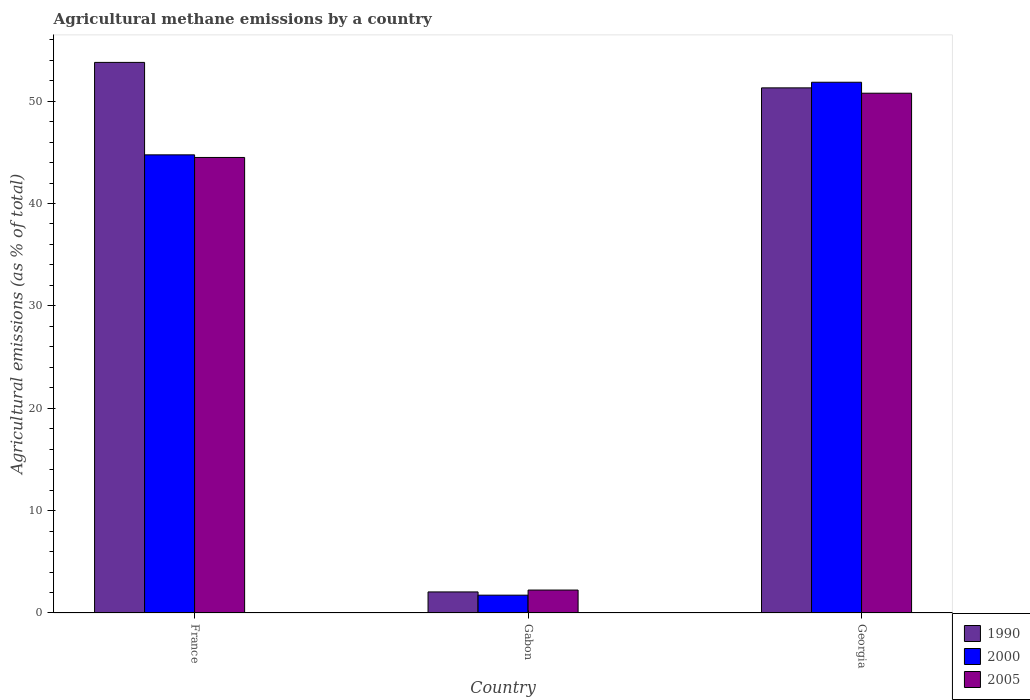How many groups of bars are there?
Keep it short and to the point. 3. Are the number of bars per tick equal to the number of legend labels?
Give a very brief answer. Yes. How many bars are there on the 1st tick from the left?
Your answer should be very brief. 3. How many bars are there on the 2nd tick from the right?
Your answer should be very brief. 3. What is the label of the 1st group of bars from the left?
Your response must be concise. France. In how many cases, is the number of bars for a given country not equal to the number of legend labels?
Your response must be concise. 0. What is the amount of agricultural methane emitted in 2005 in Gabon?
Provide a short and direct response. 2.24. Across all countries, what is the maximum amount of agricultural methane emitted in 2005?
Provide a short and direct response. 50.77. Across all countries, what is the minimum amount of agricultural methane emitted in 1990?
Your answer should be compact. 2.06. In which country was the amount of agricultural methane emitted in 2005 maximum?
Offer a very short reply. Georgia. In which country was the amount of agricultural methane emitted in 2005 minimum?
Your answer should be very brief. Gabon. What is the total amount of agricultural methane emitted in 1990 in the graph?
Keep it short and to the point. 107.14. What is the difference between the amount of agricultural methane emitted in 2000 in Gabon and that in Georgia?
Your answer should be very brief. -50.1. What is the difference between the amount of agricultural methane emitted in 1990 in Georgia and the amount of agricultural methane emitted in 2000 in France?
Your answer should be compact. 6.54. What is the average amount of agricultural methane emitted in 2000 per country?
Make the answer very short. 32.78. What is the difference between the amount of agricultural methane emitted of/in 2000 and amount of agricultural methane emitted of/in 2005 in Georgia?
Ensure brevity in your answer.  1.07. What is the ratio of the amount of agricultural methane emitted in 2005 in Gabon to that in Georgia?
Offer a terse response. 0.04. Is the amount of agricultural methane emitted in 1990 in Gabon less than that in Georgia?
Your answer should be very brief. Yes. What is the difference between the highest and the second highest amount of agricultural methane emitted in 1990?
Your answer should be compact. -49.24. What is the difference between the highest and the lowest amount of agricultural methane emitted in 2005?
Keep it short and to the point. 48.53. In how many countries, is the amount of agricultural methane emitted in 2005 greater than the average amount of agricultural methane emitted in 2005 taken over all countries?
Keep it short and to the point. 2. Is the sum of the amount of agricultural methane emitted in 2005 in Gabon and Georgia greater than the maximum amount of agricultural methane emitted in 1990 across all countries?
Make the answer very short. No. What does the 2nd bar from the left in Gabon represents?
Offer a very short reply. 2000. What does the 2nd bar from the right in Georgia represents?
Ensure brevity in your answer.  2000. Is it the case that in every country, the sum of the amount of agricultural methane emitted in 1990 and amount of agricultural methane emitted in 2000 is greater than the amount of agricultural methane emitted in 2005?
Your answer should be compact. Yes. How many bars are there?
Provide a short and direct response. 9. Are all the bars in the graph horizontal?
Offer a terse response. No. What is the difference between two consecutive major ticks on the Y-axis?
Provide a succinct answer. 10. Does the graph contain any zero values?
Your response must be concise. No. Does the graph contain grids?
Provide a short and direct response. No. How many legend labels are there?
Ensure brevity in your answer.  3. What is the title of the graph?
Offer a terse response. Agricultural methane emissions by a country. Does "1966" appear as one of the legend labels in the graph?
Make the answer very short. No. What is the label or title of the Y-axis?
Offer a terse response. Agricultural emissions (as % of total). What is the Agricultural emissions (as % of total) of 1990 in France?
Your response must be concise. 53.78. What is the Agricultural emissions (as % of total) in 2000 in France?
Give a very brief answer. 44.75. What is the Agricultural emissions (as % of total) in 2005 in France?
Your response must be concise. 44.5. What is the Agricultural emissions (as % of total) of 1990 in Gabon?
Keep it short and to the point. 2.06. What is the Agricultural emissions (as % of total) in 2000 in Gabon?
Ensure brevity in your answer.  1.74. What is the Agricultural emissions (as % of total) of 2005 in Gabon?
Offer a terse response. 2.24. What is the Agricultural emissions (as % of total) in 1990 in Georgia?
Your answer should be compact. 51.29. What is the Agricultural emissions (as % of total) of 2000 in Georgia?
Your response must be concise. 51.84. What is the Agricultural emissions (as % of total) in 2005 in Georgia?
Make the answer very short. 50.77. Across all countries, what is the maximum Agricultural emissions (as % of total) of 1990?
Provide a succinct answer. 53.78. Across all countries, what is the maximum Agricultural emissions (as % of total) of 2000?
Ensure brevity in your answer.  51.84. Across all countries, what is the maximum Agricultural emissions (as % of total) of 2005?
Your answer should be very brief. 50.77. Across all countries, what is the minimum Agricultural emissions (as % of total) in 1990?
Ensure brevity in your answer.  2.06. Across all countries, what is the minimum Agricultural emissions (as % of total) in 2000?
Give a very brief answer. 1.74. Across all countries, what is the minimum Agricultural emissions (as % of total) in 2005?
Your answer should be compact. 2.24. What is the total Agricultural emissions (as % of total) in 1990 in the graph?
Give a very brief answer. 107.14. What is the total Agricultural emissions (as % of total) of 2000 in the graph?
Your answer should be very brief. 98.34. What is the total Agricultural emissions (as % of total) in 2005 in the graph?
Give a very brief answer. 97.51. What is the difference between the Agricultural emissions (as % of total) of 1990 in France and that in Gabon?
Your answer should be very brief. 51.72. What is the difference between the Agricultural emissions (as % of total) in 2000 in France and that in Gabon?
Ensure brevity in your answer.  43.01. What is the difference between the Agricultural emissions (as % of total) in 2005 in France and that in Gabon?
Provide a short and direct response. 42.26. What is the difference between the Agricultural emissions (as % of total) in 1990 in France and that in Georgia?
Your answer should be compact. 2.49. What is the difference between the Agricultural emissions (as % of total) in 2000 in France and that in Georgia?
Ensure brevity in your answer.  -7.09. What is the difference between the Agricultural emissions (as % of total) of 2005 in France and that in Georgia?
Keep it short and to the point. -6.28. What is the difference between the Agricultural emissions (as % of total) in 1990 in Gabon and that in Georgia?
Provide a short and direct response. -49.24. What is the difference between the Agricultural emissions (as % of total) in 2000 in Gabon and that in Georgia?
Your answer should be very brief. -50.1. What is the difference between the Agricultural emissions (as % of total) of 2005 in Gabon and that in Georgia?
Your response must be concise. -48.53. What is the difference between the Agricultural emissions (as % of total) in 1990 in France and the Agricultural emissions (as % of total) in 2000 in Gabon?
Provide a succinct answer. 52.04. What is the difference between the Agricultural emissions (as % of total) in 1990 in France and the Agricultural emissions (as % of total) in 2005 in Gabon?
Keep it short and to the point. 51.54. What is the difference between the Agricultural emissions (as % of total) in 2000 in France and the Agricultural emissions (as % of total) in 2005 in Gabon?
Offer a terse response. 42.51. What is the difference between the Agricultural emissions (as % of total) in 1990 in France and the Agricultural emissions (as % of total) in 2000 in Georgia?
Ensure brevity in your answer.  1.94. What is the difference between the Agricultural emissions (as % of total) of 1990 in France and the Agricultural emissions (as % of total) of 2005 in Georgia?
Make the answer very short. 3.01. What is the difference between the Agricultural emissions (as % of total) in 2000 in France and the Agricultural emissions (as % of total) in 2005 in Georgia?
Offer a terse response. -6.02. What is the difference between the Agricultural emissions (as % of total) of 1990 in Gabon and the Agricultural emissions (as % of total) of 2000 in Georgia?
Your response must be concise. -49.79. What is the difference between the Agricultural emissions (as % of total) in 1990 in Gabon and the Agricultural emissions (as % of total) in 2005 in Georgia?
Your response must be concise. -48.71. What is the difference between the Agricultural emissions (as % of total) of 2000 in Gabon and the Agricultural emissions (as % of total) of 2005 in Georgia?
Provide a short and direct response. -49.03. What is the average Agricultural emissions (as % of total) in 1990 per country?
Your answer should be very brief. 35.71. What is the average Agricultural emissions (as % of total) of 2000 per country?
Offer a very short reply. 32.78. What is the average Agricultural emissions (as % of total) in 2005 per country?
Your response must be concise. 32.5. What is the difference between the Agricultural emissions (as % of total) of 1990 and Agricultural emissions (as % of total) of 2000 in France?
Offer a terse response. 9.03. What is the difference between the Agricultural emissions (as % of total) of 1990 and Agricultural emissions (as % of total) of 2005 in France?
Keep it short and to the point. 9.28. What is the difference between the Agricultural emissions (as % of total) of 2000 and Agricultural emissions (as % of total) of 2005 in France?
Make the answer very short. 0.26. What is the difference between the Agricultural emissions (as % of total) in 1990 and Agricultural emissions (as % of total) in 2000 in Gabon?
Your answer should be very brief. 0.32. What is the difference between the Agricultural emissions (as % of total) in 1990 and Agricultural emissions (as % of total) in 2005 in Gabon?
Offer a very short reply. -0.18. What is the difference between the Agricultural emissions (as % of total) of 2000 and Agricultural emissions (as % of total) of 2005 in Gabon?
Your answer should be compact. -0.5. What is the difference between the Agricultural emissions (as % of total) in 1990 and Agricultural emissions (as % of total) in 2000 in Georgia?
Offer a terse response. -0.55. What is the difference between the Agricultural emissions (as % of total) of 1990 and Agricultural emissions (as % of total) of 2005 in Georgia?
Give a very brief answer. 0.52. What is the difference between the Agricultural emissions (as % of total) of 2000 and Agricultural emissions (as % of total) of 2005 in Georgia?
Offer a very short reply. 1.07. What is the ratio of the Agricultural emissions (as % of total) of 1990 in France to that in Gabon?
Offer a terse response. 26.13. What is the ratio of the Agricultural emissions (as % of total) in 2000 in France to that in Gabon?
Offer a terse response. 25.69. What is the ratio of the Agricultural emissions (as % of total) of 2005 in France to that in Gabon?
Your answer should be very brief. 19.86. What is the ratio of the Agricultural emissions (as % of total) of 1990 in France to that in Georgia?
Make the answer very short. 1.05. What is the ratio of the Agricultural emissions (as % of total) in 2000 in France to that in Georgia?
Make the answer very short. 0.86. What is the ratio of the Agricultural emissions (as % of total) of 2005 in France to that in Georgia?
Give a very brief answer. 0.88. What is the ratio of the Agricultural emissions (as % of total) of 1990 in Gabon to that in Georgia?
Give a very brief answer. 0.04. What is the ratio of the Agricultural emissions (as % of total) in 2000 in Gabon to that in Georgia?
Make the answer very short. 0.03. What is the ratio of the Agricultural emissions (as % of total) of 2005 in Gabon to that in Georgia?
Keep it short and to the point. 0.04. What is the difference between the highest and the second highest Agricultural emissions (as % of total) in 1990?
Give a very brief answer. 2.49. What is the difference between the highest and the second highest Agricultural emissions (as % of total) in 2000?
Your answer should be compact. 7.09. What is the difference between the highest and the second highest Agricultural emissions (as % of total) in 2005?
Give a very brief answer. 6.28. What is the difference between the highest and the lowest Agricultural emissions (as % of total) in 1990?
Ensure brevity in your answer.  51.72. What is the difference between the highest and the lowest Agricultural emissions (as % of total) of 2000?
Your answer should be compact. 50.1. What is the difference between the highest and the lowest Agricultural emissions (as % of total) of 2005?
Provide a short and direct response. 48.53. 